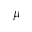<formula> <loc_0><loc_0><loc_500><loc_500>\mu</formula> 